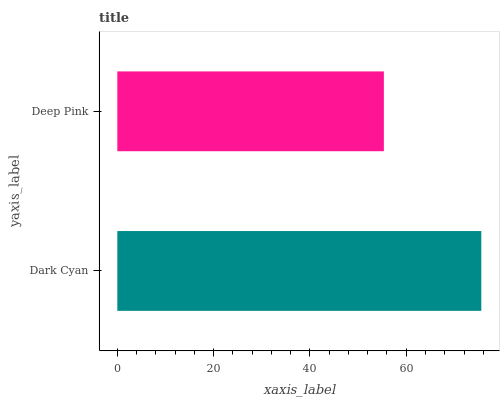Is Deep Pink the minimum?
Answer yes or no. Yes. Is Dark Cyan the maximum?
Answer yes or no. Yes. Is Deep Pink the maximum?
Answer yes or no. No. Is Dark Cyan greater than Deep Pink?
Answer yes or no. Yes. Is Deep Pink less than Dark Cyan?
Answer yes or no. Yes. Is Deep Pink greater than Dark Cyan?
Answer yes or no. No. Is Dark Cyan less than Deep Pink?
Answer yes or no. No. Is Dark Cyan the high median?
Answer yes or no. Yes. Is Deep Pink the low median?
Answer yes or no. Yes. Is Deep Pink the high median?
Answer yes or no. No. Is Dark Cyan the low median?
Answer yes or no. No. 